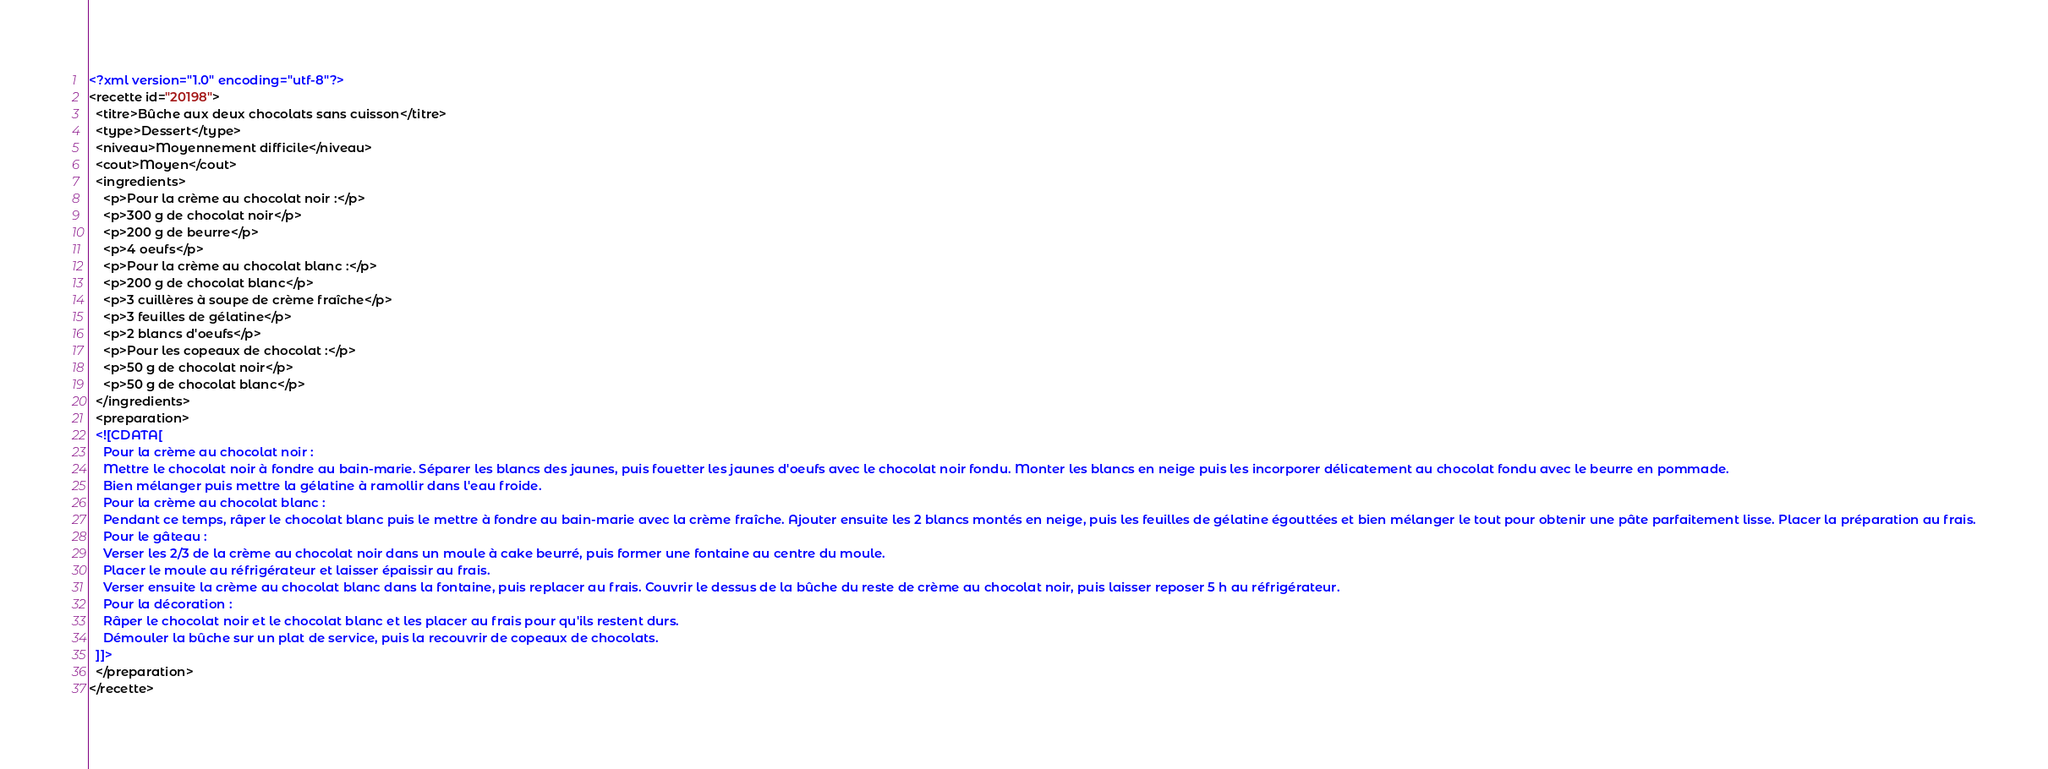Convert code to text. <code><loc_0><loc_0><loc_500><loc_500><_XML_><?xml version="1.0" encoding="utf-8"?>
<recette id="20198">
  <titre>Bûche aux deux chocolats sans cuisson</titre>
  <type>Dessert</type>
  <niveau>Moyennement difficile</niveau>
  <cout>Moyen</cout>
  <ingredients>
    <p>Pour la crème au chocolat noir :</p>
    <p>300 g de chocolat noir</p>
    <p>200 g de beurre</p>
    <p>4 oeufs</p>
    <p>Pour la crème au chocolat blanc :</p>
    <p>200 g de chocolat blanc</p>
    <p>3 cuillères à soupe de crème fraîche</p>
    <p>3 feuilles de gélatine</p>
    <p>2 blancs d'oeufs</p>
    <p>Pour les copeaux de chocolat :</p>
    <p>50 g de chocolat noir</p>
    <p>50 g de chocolat blanc</p>
  </ingredients>
  <preparation>
  <![CDATA[
    Pour la crème au chocolat noir :
    Mettre le chocolat noir à fondre au bain-marie. Séparer les blancs des jaunes, puis fouetter les jaunes d'oeufs avec le chocolat noir fondu. Monter les blancs en neige puis les incorporer délicatement au chocolat fondu avec le beurre en pommade.
    Bien mélanger puis mettre la gélatine à ramollir dans l'eau froide.
    Pour la crème au chocolat blanc :
    Pendant ce temps, râper le chocolat blanc puis le mettre à fondre au bain-marie avec la crème fraîche. Ajouter ensuite les 2 blancs montés en neige, puis les feuilles de gélatine égouttées et bien mélanger le tout pour obtenir une pâte parfaitement lisse. Placer la préparation au frais.
    Pour le gâteau :
    Verser les 2/3 de la crème au chocolat noir dans un moule à cake beurré, puis former une fontaine au centre du moule.
    Placer le moule au réfrigérateur et laisser épaissir au frais.
    Verser ensuite la crème au chocolat blanc dans la fontaine, puis replacer au frais. Couvrir le dessus de la bûche du reste de crème au chocolat noir, puis laisser reposer 5 h au réfrigérateur.
    Pour la décoration :
    Râper le chocolat noir et le chocolat blanc et les placer au frais pour qu'ils restent durs.
    Démouler la bûche sur un plat de service, puis la recouvrir de copeaux de chocolats.
  ]]>
  </preparation>
</recette>
</code> 